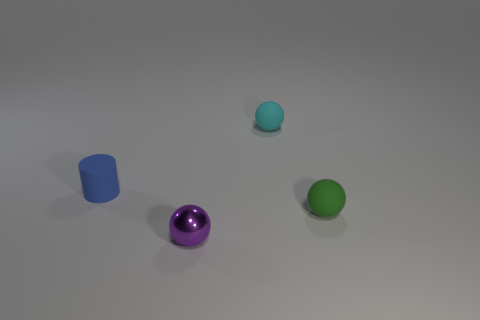Add 4 spheres. How many objects exist? 8 Subtract all cylinders. How many objects are left? 3 Add 1 cyan blocks. How many cyan blocks exist? 1 Subtract 0 red cylinders. How many objects are left? 4 Subtract all tiny matte balls. Subtract all purple balls. How many objects are left? 1 Add 2 small metal balls. How many small metal balls are left? 3 